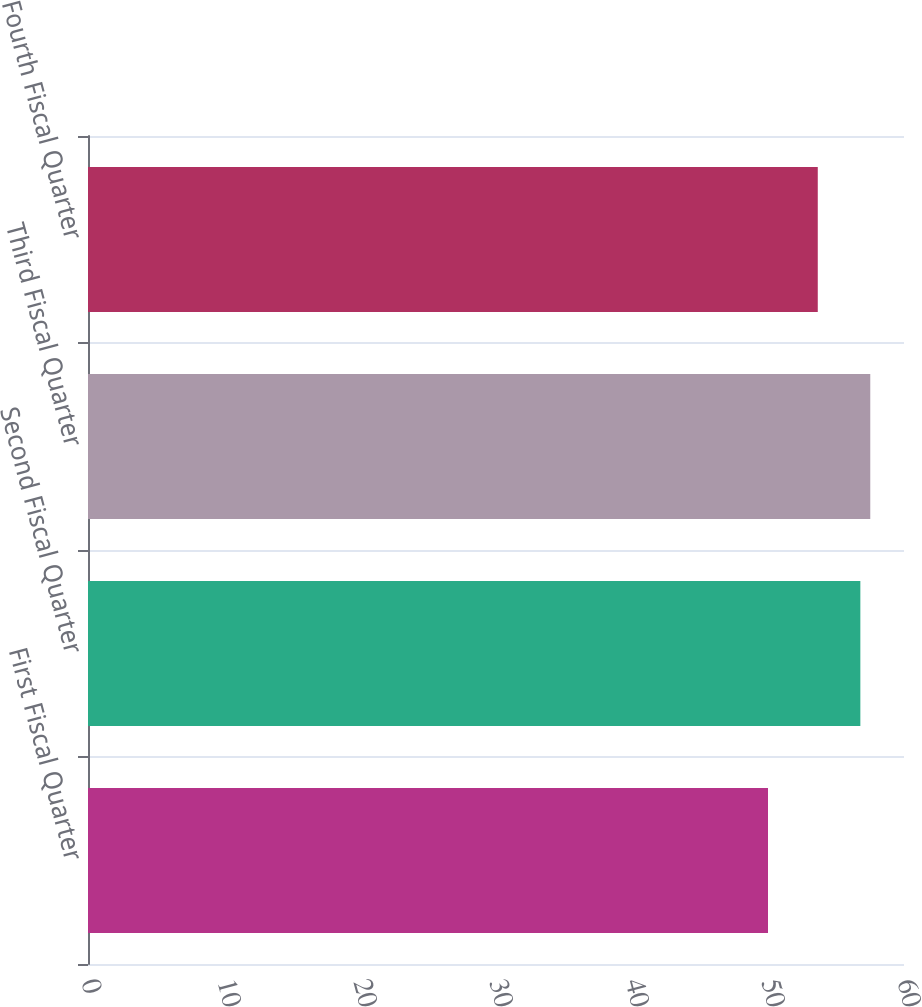Convert chart to OTSL. <chart><loc_0><loc_0><loc_500><loc_500><bar_chart><fcel>First Fiscal Quarter<fcel>Second Fiscal Quarter<fcel>Third Fiscal Quarter<fcel>Fourth Fiscal Quarter<nl><fcel>50<fcel>56.79<fcel>57.52<fcel>53.66<nl></chart> 